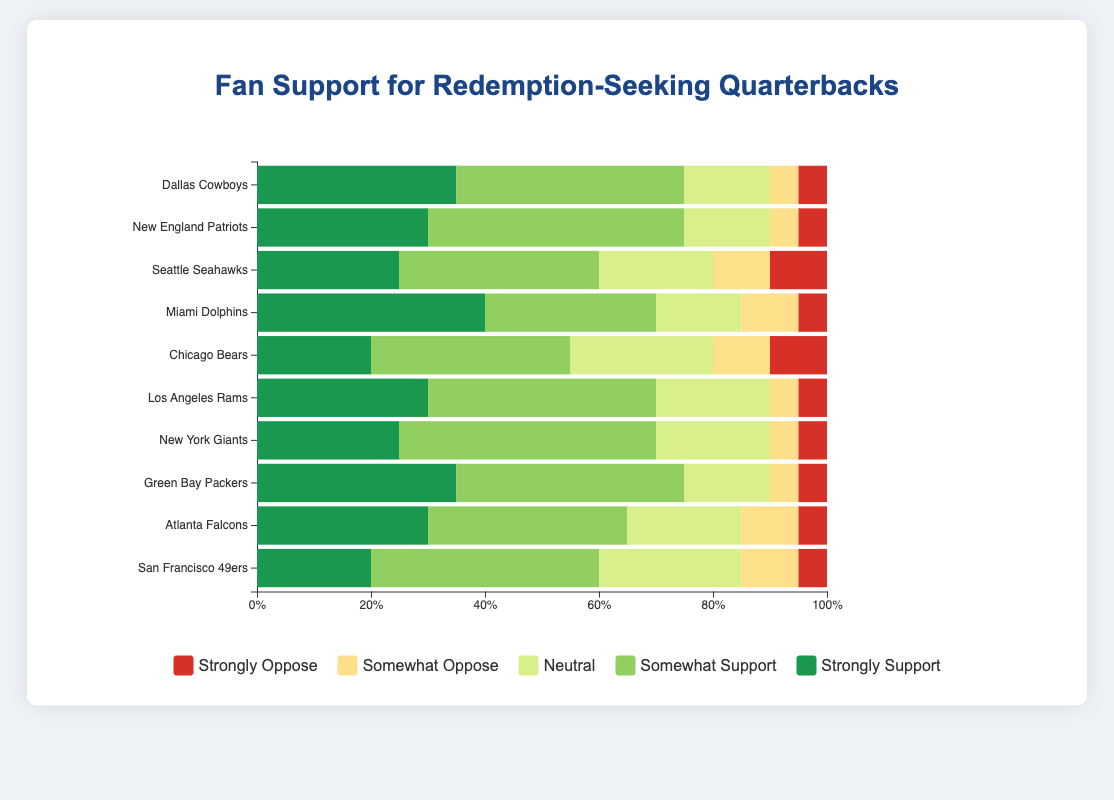What's the total percentage of fan support (strongly support + somewhat support) for the Chicago Bears? Summing the percentages of "strongly support" (20%) and "somewhat support" (35%) for the Chicago Bears gives us 20 + 35.
Answer: 55% Which team in the Southeast region has the highest percentage of "neutral" fans? Comparing the "neutral" percentages among Southeast teams (Miami Dolphins and Atlanta Falcons), Dolphins have 15% and Falcons have 20%. The higher value is 20% for the Falcons.
Answer: Atlanta Falcons How does the "strongly oppose" support level for the Los Angeles Rams compare to that of the New England Patriots? Both teams have the same "strongly oppose" percentage of 5%.
Answer: Equal (5%) Which team has the smallest percentage of "somewhat support" fans? By inspecting the "somewhat support" percentages for each team, the smallest is the Seahawks with 35% compared to others.
Answer: Seattle Seahawks What's the average percentage of "strongly support" across all teams? Adding the "strongly support" percentages for all teams and dividing by the number of teams: (35 + 30 + 25 + 40 + 20 + 30 + 25 + 35 + 30 + 20) / 10. The sum is 290, and the average is 290 / 10.
Answer: 29% Between the New York Giants and the San Francisco 49ers, which team has a higher combined percentage of "somewhat support" and "neutral"? New York Giants have 45% (somewhat support) + 20% (neutral) = 65%; San Francisco 49ers have 40% (somewhat support) + 25% (neutral) = 65%.
Answer: Equal (65%) Which region shows the highest level of "strongly support" across its teams? Summing "strongly support" for each region: Northeast (30 + 25), Southeast (40 + 30), Midwest (20 + 35), Southwest (35), Northwest (25), West Coast (30 + 20). The highest sum is Southeast (40 + 30 = 70).
Answer: Southeast Compare the percentage of "somewhat oppose" between the Seattle Seahawks and the Green Bay Packers. Seahawks have 10% "somewhat oppose" and Packers have 5%.
Answer: Seahawks (10%) > Packers (5%) 